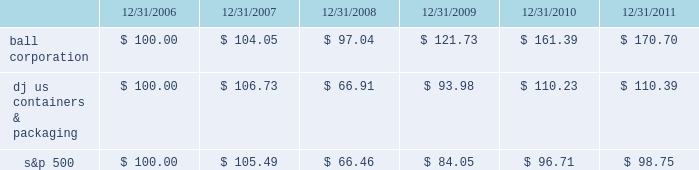Shareholder return performance the line graph below compares the annual percentage change in ball corporation fffds cumulative total shareholder return on its common stock with the cumulative total return of the dow jones containers & packaging index and the s&p composite 500 stock index for the five-year period ended december 31 , 2011 .
It assumes $ 100 was invested on december 31 , 2006 , and that all dividends were reinvested .
The dow jones containers & packaging index total return has been weighted by market capitalization .
Total return to stockholders ( assumes $ 100 investment on 12/31/06 ) total return analysis .
Copyright a9 2012 standard & poor fffds , a division of the mcgraw-hill companies inc .
All rights reserved .
( www.researchdatagroup.com/s&p.htm ) copyright a9 2012 dow jones & company .
All rights reserved. .
What is the roi of an investment in dj us containers & packaging from 2006 to 2008? 
Computations: ((66.91 - 100) / 100)
Answer: -0.3309. 